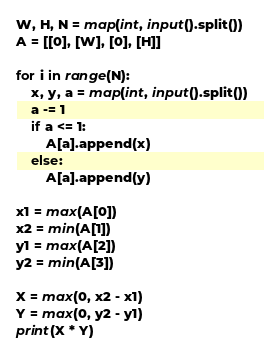<code> <loc_0><loc_0><loc_500><loc_500><_Python_>W, H, N = map(int, input().split())
A = [[0], [W], [0], [H]]

for i in range(N):
    x, y, a = map(int, input().split())
    a -= 1
    if a <= 1:
        A[a].append(x)
    else:
        A[a].append(y)

x1 = max(A[0])
x2 = min(A[1])
y1 = max(A[2])
y2 = min(A[3])

X = max(0, x2 - x1)
Y = max(0, y2 - y1)
print(X * Y)
</code> 